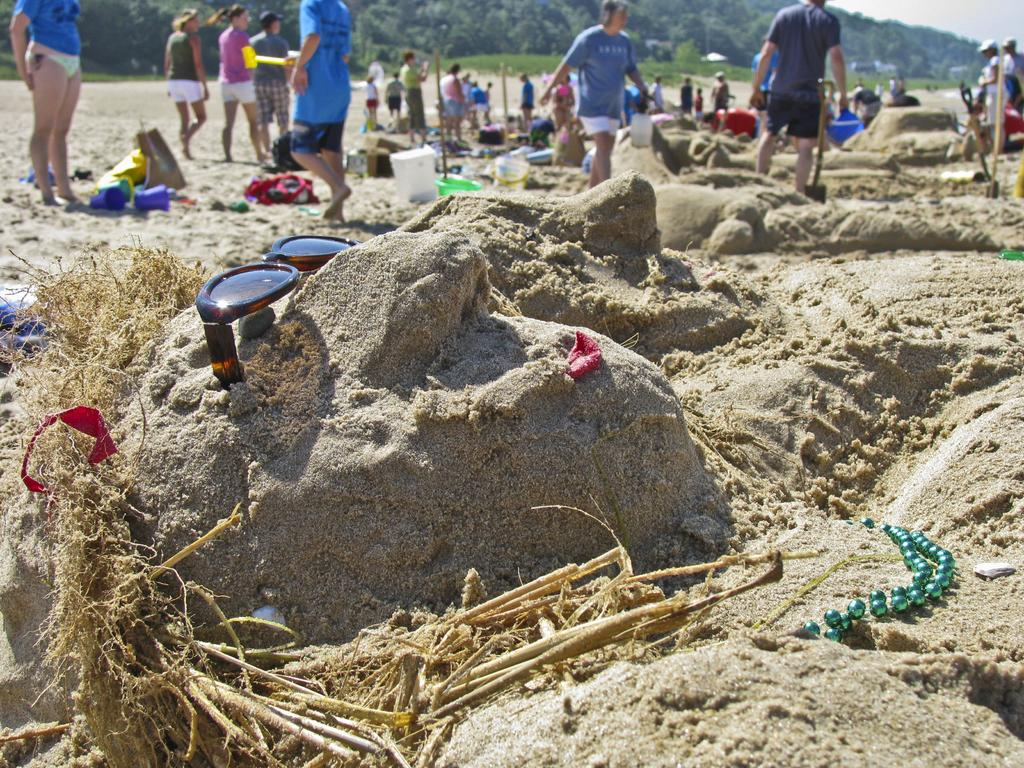What is at the bottom of the image? There is sand at the bottom of the image. What accessory can be seen in the image? There are sunglasses in the image. Who or what is present in the image? There are people in the image. What can be seen in the distance in the image? There are trees and mountains in the background of the image. What type of cork can be seen floating in the water in the image? There is no water or cork present in the image; it features sand at the bottom and sunglasses. How many balloons are tied to the people in the image? There are no balloons present in the image; it features people without any balloons. 